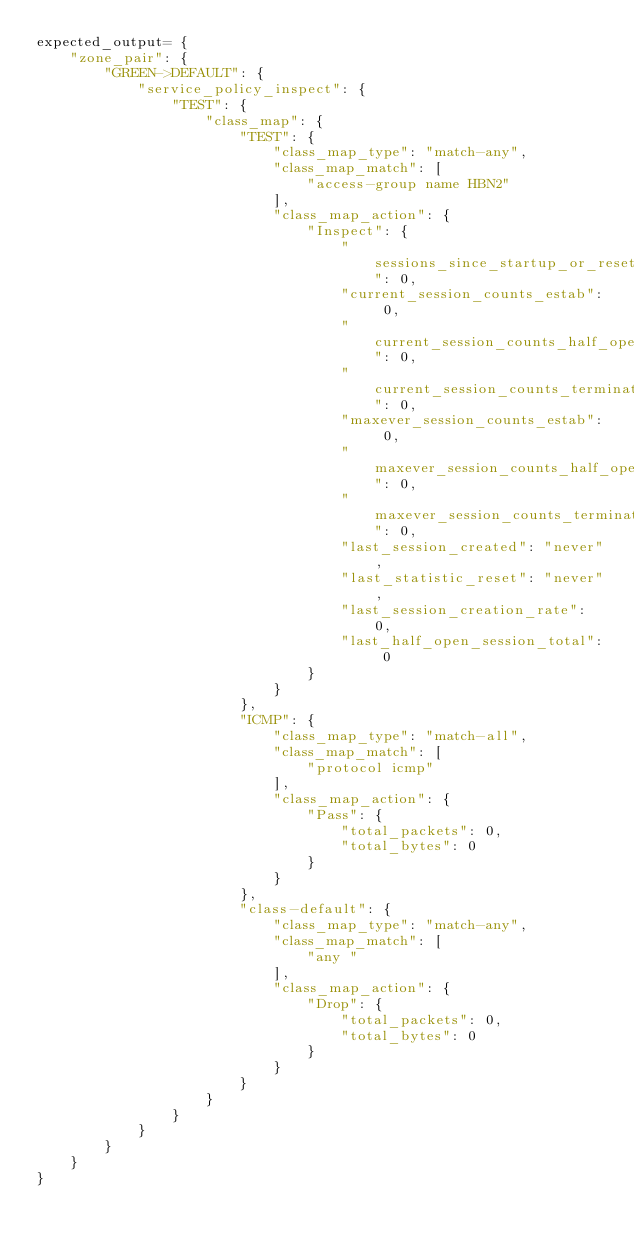Convert code to text. <code><loc_0><loc_0><loc_500><loc_500><_Python_>expected_output= {
    "zone_pair": {
        "GREEN->DEFAULT": {
            "service_policy_inspect": {
                "TEST": {
                    "class_map": {
                        "TEST": {
                            "class_map_type": "match-any",
                            "class_map_match": [
                                "access-group name HBN2"
                            ],
                            "class_map_action": {
                                "Inspect": {
                                    "sessions_since_startup_or_reset": 0,
                                    "current_session_counts_estab": 0,
                                    "current_session_counts_half_open": 0,
                                    "current_session_counts_terminating": 0,
                                    "maxever_session_counts_estab": 0,
                                    "maxever_session_counts_half_open": 0,
                                    "maxever_session_counts_terminating": 0,
                                    "last_session_created": "never",
                                    "last_statistic_reset": "never",
                                    "last_session_creation_rate": 0,
                                    "last_half_open_session_total": 0
                                }
                            }
                        },
                        "ICMP": {
                            "class_map_type": "match-all",
                            "class_map_match": [
                                "protocol icmp"
                            ],
                            "class_map_action": {
                                "Pass": {
                                    "total_packets": 0,
                                    "total_bytes": 0
                                }
                            }
                        },
                        "class-default": {
                            "class_map_type": "match-any",
                            "class_map_match": [
                                "any "
                            ],
                            "class_map_action": {
                                "Drop": {
                                    "total_packets": 0,
                                    "total_bytes": 0
                                }
                            }
                        }
                    }
                }
            }
        }
    }
}</code> 